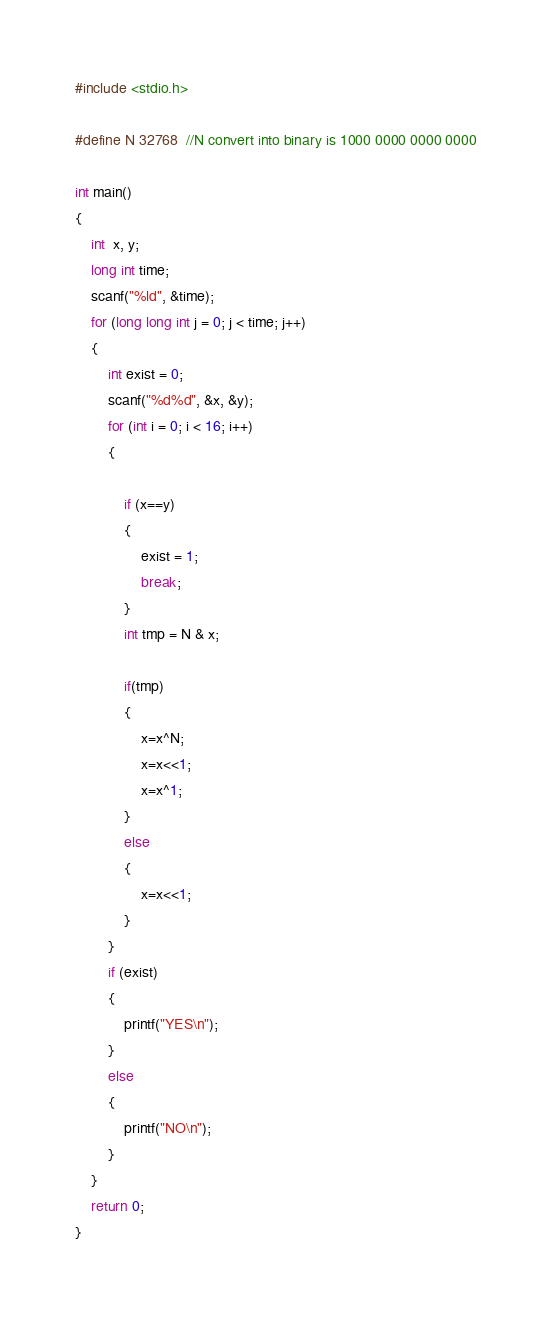<code> <loc_0><loc_0><loc_500><loc_500><_C_>#include <stdio.h>

#define N 32768  //N convert into binary is 1000 0000 0000 0000

int main()
{
    int  x, y;
    long int time;
    scanf("%ld", &time);
    for (long long int j = 0; j < time; j++)
    {
        int exist = 0;
        scanf("%d%d", &x, &y);
        for (int i = 0; i < 16; i++)
        {

            if (x==y)
            {
                exist = 1;
                break;
            }
            int tmp = N & x;

            if(tmp)
            {
                x=x^N;
                x=x<<1;
                x=x^1;
            }
            else
            {
                x=x<<1;
            }
        }
        if (exist)
        {
            printf("YES\n");
        }
        else
        {
            printf("NO\n");
        }
    }
    return 0;
}
</code> 